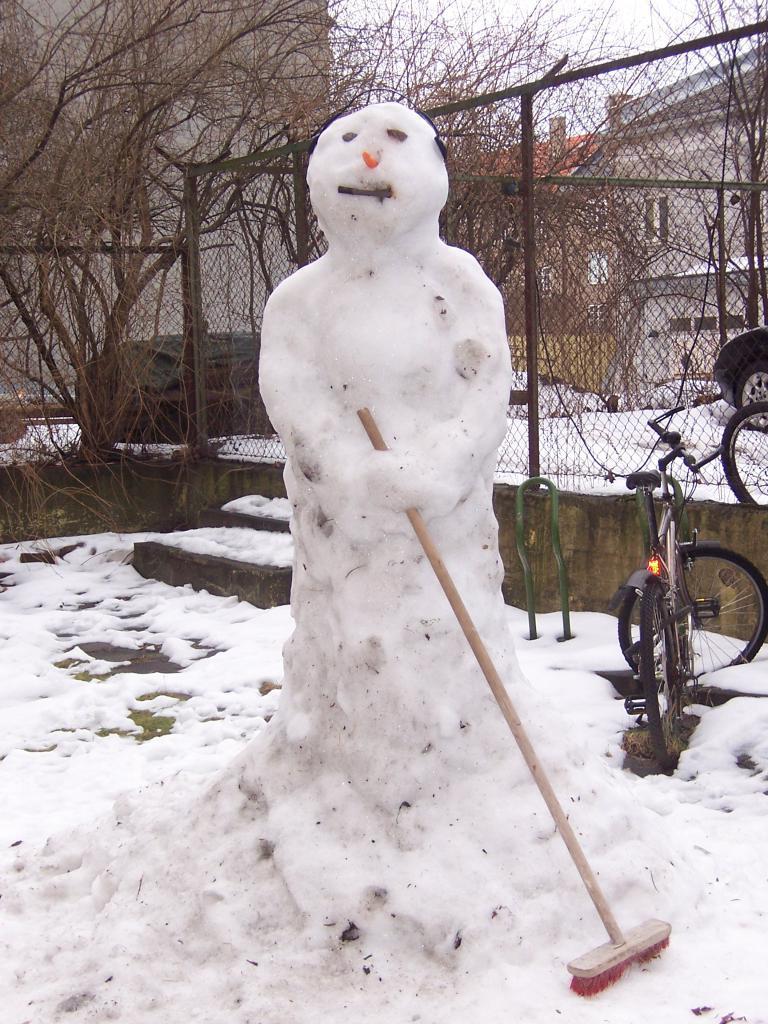In one or two sentences, can you explain what this image depicts? In this image in the foreground there is a snowman who is holding a brush, and in the background there is snow, net, stairs, cycles and there are buildings and trees. 